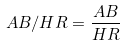Convert formula to latex. <formula><loc_0><loc_0><loc_500><loc_500>A B / H R = \frac { A B } { H R }</formula> 